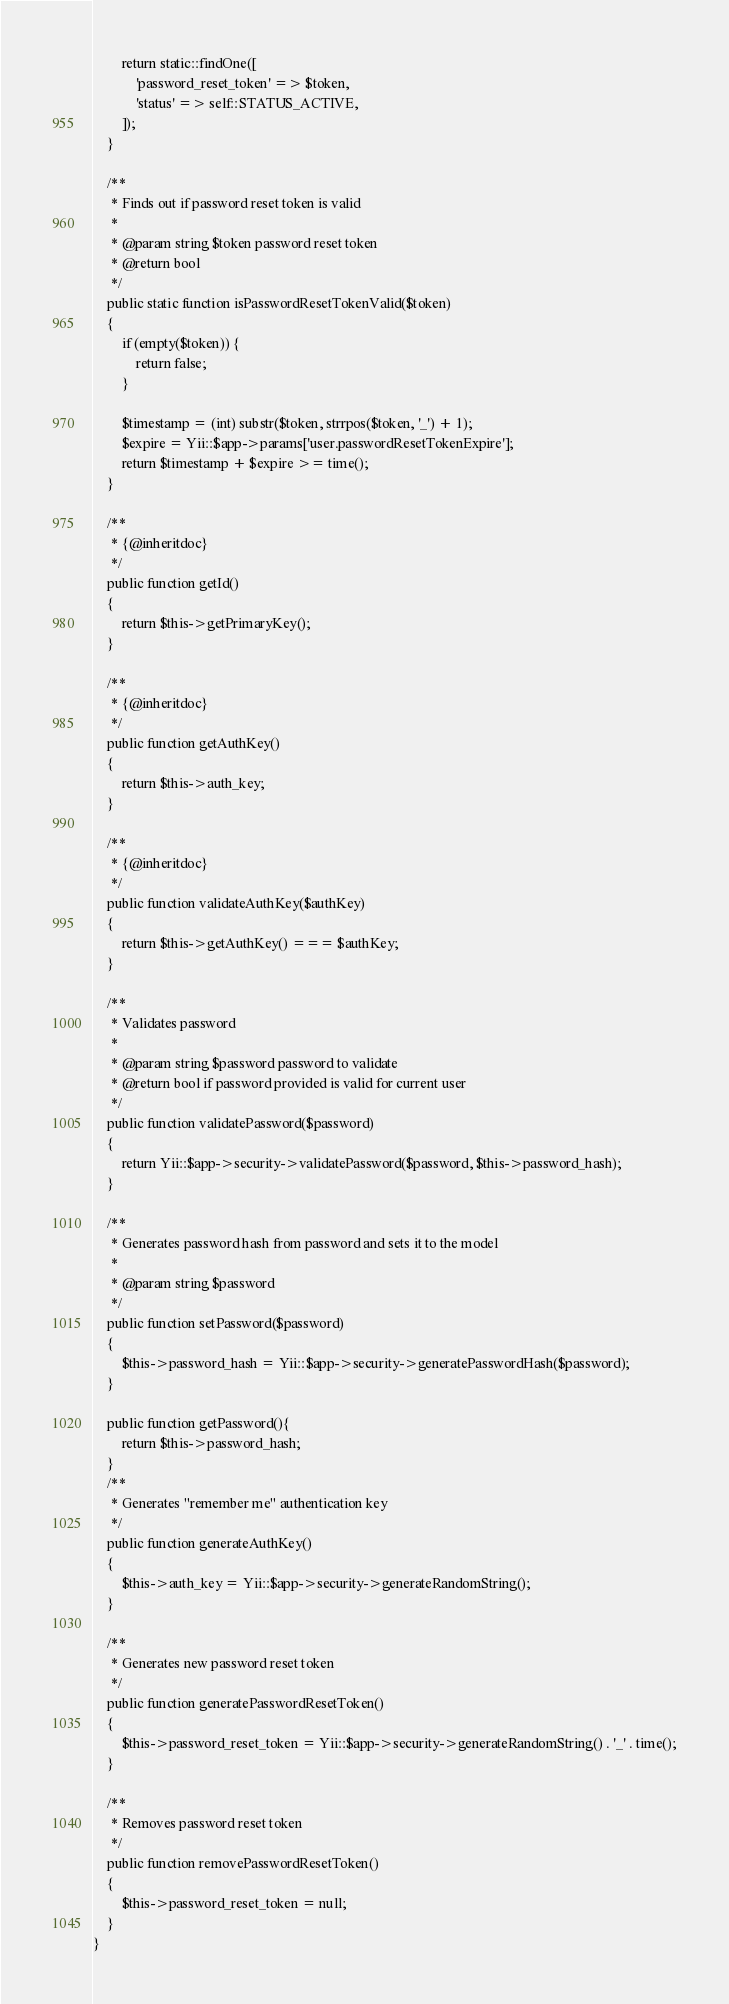Convert code to text. <code><loc_0><loc_0><loc_500><loc_500><_PHP_>
        return static::findOne([
            'password_reset_token' => $token,
            'status' => self::STATUS_ACTIVE,
        ]);
    }

    /**
     * Finds out if password reset token is valid
     *
     * @param string $token password reset token
     * @return bool
     */
    public static function isPasswordResetTokenValid($token)
    {
        if (empty($token)) {
            return false;
        }

        $timestamp = (int) substr($token, strrpos($token, '_') + 1);
        $expire = Yii::$app->params['user.passwordResetTokenExpire'];
        return $timestamp + $expire >= time();
    }

    /**
     * {@inheritdoc}
     */
    public function getId()
    {
        return $this->getPrimaryKey();
    }

    /**
     * {@inheritdoc}
     */
    public function getAuthKey()
    {
        return $this->auth_key;
    }

    /**
     * {@inheritdoc}
     */
    public function validateAuthKey($authKey)
    {
        return $this->getAuthKey() === $authKey;
    }

    /**
     * Validates password
     *
     * @param string $password password to validate
     * @return bool if password provided is valid for current user
     */
    public function validatePassword($password)
    {
        return Yii::$app->security->validatePassword($password, $this->password_hash);
    }

    /**
     * Generates password hash from password and sets it to the model
     *
     * @param string $password
     */
    public function setPassword($password)
    {
        $this->password_hash = Yii::$app->security->generatePasswordHash($password);
    }

    public function getPassword(){
        return $this->password_hash;
    }
    /**
     * Generates "remember me" authentication key
     */
    public function generateAuthKey()
    {
        $this->auth_key = Yii::$app->security->generateRandomString();
    }

    /**
     * Generates new password reset token
     */
    public function generatePasswordResetToken()
    {
        $this->password_reset_token = Yii::$app->security->generateRandomString() . '_' . time();
    }

    /**
     * Removes password reset token
     */
    public function removePasswordResetToken()
    {
        $this->password_reset_token = null;
    }
}
</code> 